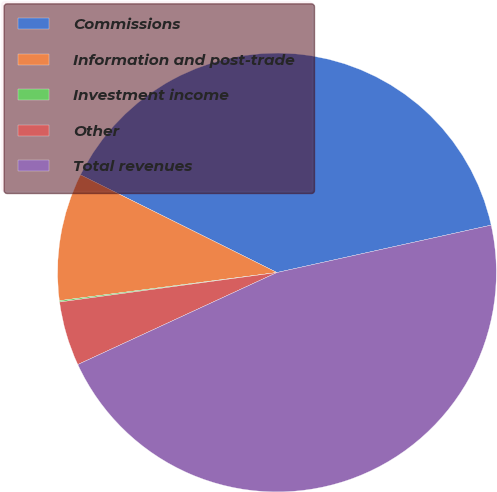Convert chart. <chart><loc_0><loc_0><loc_500><loc_500><pie_chart><fcel>Commissions<fcel>Information and post-trade<fcel>Investment income<fcel>Other<fcel>Total revenues<nl><fcel>39.19%<fcel>9.39%<fcel>0.1%<fcel>4.74%<fcel>46.57%<nl></chart> 